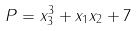<formula> <loc_0><loc_0><loc_500><loc_500>P = x _ { 3 } ^ { 3 } + x _ { 1 } x _ { 2 } + 7</formula> 